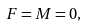Convert formula to latex. <formula><loc_0><loc_0><loc_500><loc_500>F = M = 0 ,</formula> 